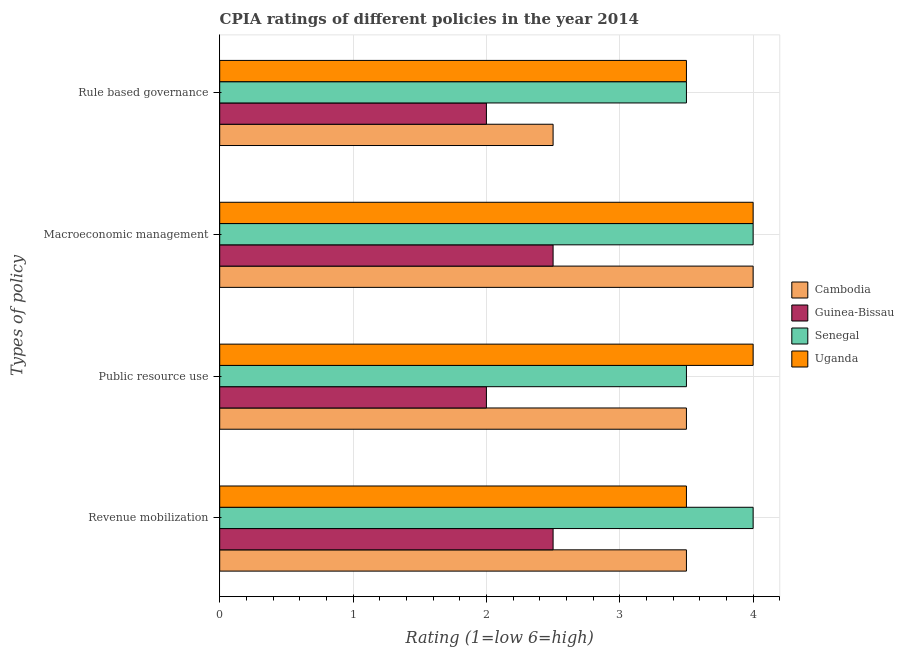How many different coloured bars are there?
Provide a succinct answer. 4. Are the number of bars on each tick of the Y-axis equal?
Keep it short and to the point. Yes. How many bars are there on the 4th tick from the top?
Your answer should be compact. 4. What is the label of the 2nd group of bars from the top?
Give a very brief answer. Macroeconomic management. Across all countries, what is the minimum cpia rating of rule based governance?
Offer a terse response. 2. In which country was the cpia rating of macroeconomic management maximum?
Give a very brief answer. Cambodia. In which country was the cpia rating of revenue mobilization minimum?
Provide a succinct answer. Guinea-Bissau. What is the total cpia rating of revenue mobilization in the graph?
Ensure brevity in your answer.  13.5. What is the difference between the cpia rating of revenue mobilization in Uganda and the cpia rating of rule based governance in Guinea-Bissau?
Make the answer very short. 1.5. What is the average cpia rating of revenue mobilization per country?
Make the answer very short. 3.38. In how many countries, is the cpia rating of macroeconomic management greater than 3.2 ?
Your answer should be very brief. 3. What is the ratio of the cpia rating of macroeconomic management in Cambodia to that in Uganda?
Offer a very short reply. 1. Is the cpia rating of public resource use in Cambodia less than that in Uganda?
Offer a terse response. Yes. Is the difference between the cpia rating of public resource use in Senegal and Uganda greater than the difference between the cpia rating of rule based governance in Senegal and Uganda?
Your answer should be very brief. No. Is the sum of the cpia rating of revenue mobilization in Uganda and Guinea-Bissau greater than the maximum cpia rating of macroeconomic management across all countries?
Keep it short and to the point. Yes. Is it the case that in every country, the sum of the cpia rating of rule based governance and cpia rating of revenue mobilization is greater than the sum of cpia rating of macroeconomic management and cpia rating of public resource use?
Your response must be concise. No. What does the 4th bar from the top in Rule based governance represents?
Provide a short and direct response. Cambodia. What does the 2nd bar from the bottom in Public resource use represents?
Ensure brevity in your answer.  Guinea-Bissau. What is the difference between two consecutive major ticks on the X-axis?
Your answer should be compact. 1. Does the graph contain grids?
Give a very brief answer. Yes. Where does the legend appear in the graph?
Make the answer very short. Center right. How are the legend labels stacked?
Offer a terse response. Vertical. What is the title of the graph?
Provide a succinct answer. CPIA ratings of different policies in the year 2014. Does "Belarus" appear as one of the legend labels in the graph?
Your answer should be very brief. No. What is the label or title of the Y-axis?
Ensure brevity in your answer.  Types of policy. What is the Rating (1=low 6=high) of Uganda in Revenue mobilization?
Offer a very short reply. 3.5. What is the Rating (1=low 6=high) in Guinea-Bissau in Public resource use?
Make the answer very short. 2. What is the Rating (1=low 6=high) of Uganda in Public resource use?
Provide a succinct answer. 4. What is the Rating (1=low 6=high) of Cambodia in Macroeconomic management?
Make the answer very short. 4. What is the Rating (1=low 6=high) in Cambodia in Rule based governance?
Offer a terse response. 2.5. What is the Rating (1=low 6=high) in Guinea-Bissau in Rule based governance?
Your answer should be compact. 2. What is the Rating (1=low 6=high) in Senegal in Rule based governance?
Make the answer very short. 3.5. What is the Rating (1=low 6=high) of Uganda in Rule based governance?
Offer a very short reply. 3.5. Across all Types of policy, what is the minimum Rating (1=low 6=high) in Cambodia?
Give a very brief answer. 2.5. Across all Types of policy, what is the minimum Rating (1=low 6=high) in Guinea-Bissau?
Your answer should be compact. 2. Across all Types of policy, what is the minimum Rating (1=low 6=high) in Uganda?
Keep it short and to the point. 3.5. What is the total Rating (1=low 6=high) of Senegal in the graph?
Your answer should be very brief. 15. What is the total Rating (1=low 6=high) of Uganda in the graph?
Make the answer very short. 15. What is the difference between the Rating (1=low 6=high) in Cambodia in Revenue mobilization and that in Public resource use?
Offer a terse response. 0. What is the difference between the Rating (1=low 6=high) of Guinea-Bissau in Revenue mobilization and that in Macroeconomic management?
Your answer should be compact. 0. What is the difference between the Rating (1=low 6=high) of Senegal in Revenue mobilization and that in Macroeconomic management?
Offer a terse response. 0. What is the difference between the Rating (1=low 6=high) in Uganda in Revenue mobilization and that in Macroeconomic management?
Offer a terse response. -0.5. What is the difference between the Rating (1=low 6=high) of Cambodia in Revenue mobilization and that in Rule based governance?
Keep it short and to the point. 1. What is the difference between the Rating (1=low 6=high) in Guinea-Bissau in Revenue mobilization and that in Rule based governance?
Ensure brevity in your answer.  0.5. What is the difference between the Rating (1=low 6=high) of Uganda in Revenue mobilization and that in Rule based governance?
Offer a very short reply. 0. What is the difference between the Rating (1=low 6=high) of Cambodia in Public resource use and that in Macroeconomic management?
Give a very brief answer. -0.5. What is the difference between the Rating (1=low 6=high) of Cambodia in Public resource use and that in Rule based governance?
Offer a very short reply. 1. What is the difference between the Rating (1=low 6=high) in Senegal in Public resource use and that in Rule based governance?
Offer a very short reply. 0. What is the difference between the Rating (1=low 6=high) of Uganda in Public resource use and that in Rule based governance?
Offer a very short reply. 0.5. What is the difference between the Rating (1=low 6=high) in Senegal in Macroeconomic management and that in Rule based governance?
Ensure brevity in your answer.  0.5. What is the difference between the Rating (1=low 6=high) in Uganda in Macroeconomic management and that in Rule based governance?
Provide a succinct answer. 0.5. What is the difference between the Rating (1=low 6=high) of Cambodia in Revenue mobilization and the Rating (1=low 6=high) of Guinea-Bissau in Public resource use?
Make the answer very short. 1.5. What is the difference between the Rating (1=low 6=high) of Cambodia in Revenue mobilization and the Rating (1=low 6=high) of Senegal in Public resource use?
Provide a short and direct response. 0. What is the difference between the Rating (1=low 6=high) in Cambodia in Revenue mobilization and the Rating (1=low 6=high) in Uganda in Public resource use?
Give a very brief answer. -0.5. What is the difference between the Rating (1=low 6=high) of Senegal in Revenue mobilization and the Rating (1=low 6=high) of Uganda in Public resource use?
Your response must be concise. 0. What is the difference between the Rating (1=low 6=high) in Cambodia in Revenue mobilization and the Rating (1=low 6=high) in Senegal in Macroeconomic management?
Your answer should be very brief. -0.5. What is the difference between the Rating (1=low 6=high) of Cambodia in Revenue mobilization and the Rating (1=low 6=high) of Uganda in Macroeconomic management?
Make the answer very short. -0.5. What is the difference between the Rating (1=low 6=high) of Guinea-Bissau in Revenue mobilization and the Rating (1=low 6=high) of Uganda in Macroeconomic management?
Your answer should be compact. -1.5. What is the difference between the Rating (1=low 6=high) of Senegal in Revenue mobilization and the Rating (1=low 6=high) of Uganda in Macroeconomic management?
Your answer should be very brief. 0. What is the difference between the Rating (1=low 6=high) in Cambodia in Revenue mobilization and the Rating (1=low 6=high) in Uganda in Rule based governance?
Your answer should be compact. 0. What is the difference between the Rating (1=low 6=high) of Guinea-Bissau in Revenue mobilization and the Rating (1=low 6=high) of Senegal in Rule based governance?
Your answer should be compact. -1. What is the difference between the Rating (1=low 6=high) in Senegal in Revenue mobilization and the Rating (1=low 6=high) in Uganda in Rule based governance?
Keep it short and to the point. 0.5. What is the difference between the Rating (1=low 6=high) in Cambodia in Public resource use and the Rating (1=low 6=high) in Senegal in Macroeconomic management?
Keep it short and to the point. -0.5. What is the difference between the Rating (1=low 6=high) in Cambodia in Public resource use and the Rating (1=low 6=high) in Uganda in Macroeconomic management?
Offer a very short reply. -0.5. What is the difference between the Rating (1=low 6=high) of Guinea-Bissau in Public resource use and the Rating (1=low 6=high) of Uganda in Macroeconomic management?
Your response must be concise. -2. What is the difference between the Rating (1=low 6=high) in Senegal in Public resource use and the Rating (1=low 6=high) in Uganda in Macroeconomic management?
Give a very brief answer. -0.5. What is the difference between the Rating (1=low 6=high) of Cambodia in Public resource use and the Rating (1=low 6=high) of Senegal in Rule based governance?
Make the answer very short. 0. What is the difference between the Rating (1=low 6=high) in Cambodia in Public resource use and the Rating (1=low 6=high) in Uganda in Rule based governance?
Your response must be concise. 0. What is the difference between the Rating (1=low 6=high) of Senegal in Public resource use and the Rating (1=low 6=high) of Uganda in Rule based governance?
Offer a very short reply. 0. What is the difference between the Rating (1=low 6=high) in Cambodia in Macroeconomic management and the Rating (1=low 6=high) in Senegal in Rule based governance?
Offer a very short reply. 0.5. What is the difference between the Rating (1=low 6=high) of Guinea-Bissau in Macroeconomic management and the Rating (1=low 6=high) of Uganda in Rule based governance?
Offer a very short reply. -1. What is the average Rating (1=low 6=high) in Cambodia per Types of policy?
Your response must be concise. 3.38. What is the average Rating (1=low 6=high) in Guinea-Bissau per Types of policy?
Your answer should be very brief. 2.25. What is the average Rating (1=low 6=high) in Senegal per Types of policy?
Ensure brevity in your answer.  3.75. What is the average Rating (1=low 6=high) of Uganda per Types of policy?
Keep it short and to the point. 3.75. What is the difference between the Rating (1=low 6=high) of Cambodia and Rating (1=low 6=high) of Senegal in Revenue mobilization?
Your answer should be very brief. -0.5. What is the difference between the Rating (1=low 6=high) of Guinea-Bissau and Rating (1=low 6=high) of Senegal in Revenue mobilization?
Provide a succinct answer. -1.5. What is the difference between the Rating (1=low 6=high) in Guinea-Bissau and Rating (1=low 6=high) in Uganda in Revenue mobilization?
Make the answer very short. -1. What is the difference between the Rating (1=low 6=high) of Cambodia and Rating (1=low 6=high) of Senegal in Public resource use?
Offer a terse response. 0. What is the difference between the Rating (1=low 6=high) in Cambodia and Rating (1=low 6=high) in Uganda in Public resource use?
Ensure brevity in your answer.  -0.5. What is the difference between the Rating (1=low 6=high) of Senegal and Rating (1=low 6=high) of Uganda in Public resource use?
Offer a terse response. -0.5. What is the difference between the Rating (1=low 6=high) in Guinea-Bissau and Rating (1=low 6=high) in Senegal in Macroeconomic management?
Your answer should be very brief. -1.5. What is the difference between the Rating (1=low 6=high) in Senegal and Rating (1=low 6=high) in Uganda in Macroeconomic management?
Make the answer very short. 0. What is the difference between the Rating (1=low 6=high) of Cambodia and Rating (1=low 6=high) of Guinea-Bissau in Rule based governance?
Keep it short and to the point. 0.5. What is the difference between the Rating (1=low 6=high) in Cambodia and Rating (1=low 6=high) in Senegal in Rule based governance?
Your response must be concise. -1. What is the difference between the Rating (1=low 6=high) in Cambodia and Rating (1=low 6=high) in Uganda in Rule based governance?
Your answer should be compact. -1. What is the difference between the Rating (1=low 6=high) of Guinea-Bissau and Rating (1=low 6=high) of Senegal in Rule based governance?
Provide a succinct answer. -1.5. What is the difference between the Rating (1=low 6=high) of Guinea-Bissau and Rating (1=low 6=high) of Uganda in Rule based governance?
Offer a very short reply. -1.5. What is the difference between the Rating (1=low 6=high) in Senegal and Rating (1=low 6=high) in Uganda in Rule based governance?
Your answer should be very brief. 0. What is the ratio of the Rating (1=low 6=high) in Guinea-Bissau in Revenue mobilization to that in Public resource use?
Ensure brevity in your answer.  1.25. What is the ratio of the Rating (1=low 6=high) in Senegal in Revenue mobilization to that in Public resource use?
Make the answer very short. 1.14. What is the ratio of the Rating (1=low 6=high) in Cambodia in Revenue mobilization to that in Macroeconomic management?
Provide a succinct answer. 0.88. What is the ratio of the Rating (1=low 6=high) of Cambodia in Revenue mobilization to that in Rule based governance?
Your answer should be compact. 1.4. What is the ratio of the Rating (1=low 6=high) in Guinea-Bissau in Revenue mobilization to that in Rule based governance?
Make the answer very short. 1.25. What is the ratio of the Rating (1=low 6=high) of Senegal in Revenue mobilization to that in Rule based governance?
Your answer should be very brief. 1.14. What is the ratio of the Rating (1=low 6=high) of Guinea-Bissau in Public resource use to that in Macroeconomic management?
Make the answer very short. 0.8. What is the ratio of the Rating (1=low 6=high) in Senegal in Public resource use to that in Macroeconomic management?
Offer a very short reply. 0.88. What is the ratio of the Rating (1=low 6=high) in Cambodia in Public resource use to that in Rule based governance?
Make the answer very short. 1.4. What is the ratio of the Rating (1=low 6=high) in Cambodia in Macroeconomic management to that in Rule based governance?
Offer a terse response. 1.6. What is the ratio of the Rating (1=low 6=high) in Senegal in Macroeconomic management to that in Rule based governance?
Offer a very short reply. 1.14. What is the ratio of the Rating (1=low 6=high) in Uganda in Macroeconomic management to that in Rule based governance?
Provide a short and direct response. 1.14. What is the difference between the highest and the second highest Rating (1=low 6=high) in Guinea-Bissau?
Your response must be concise. 0. What is the difference between the highest and the second highest Rating (1=low 6=high) of Senegal?
Provide a succinct answer. 0. What is the difference between the highest and the second highest Rating (1=low 6=high) of Uganda?
Make the answer very short. 0. What is the difference between the highest and the lowest Rating (1=low 6=high) in Guinea-Bissau?
Ensure brevity in your answer.  0.5. What is the difference between the highest and the lowest Rating (1=low 6=high) of Senegal?
Keep it short and to the point. 0.5. What is the difference between the highest and the lowest Rating (1=low 6=high) in Uganda?
Ensure brevity in your answer.  0.5. 